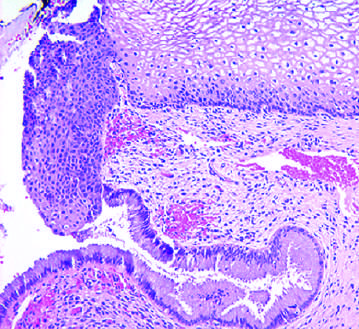what did ervical transformation zone show?
Answer the question using a single word or phrase. The transition from mature glycogenated squamous epithelium 